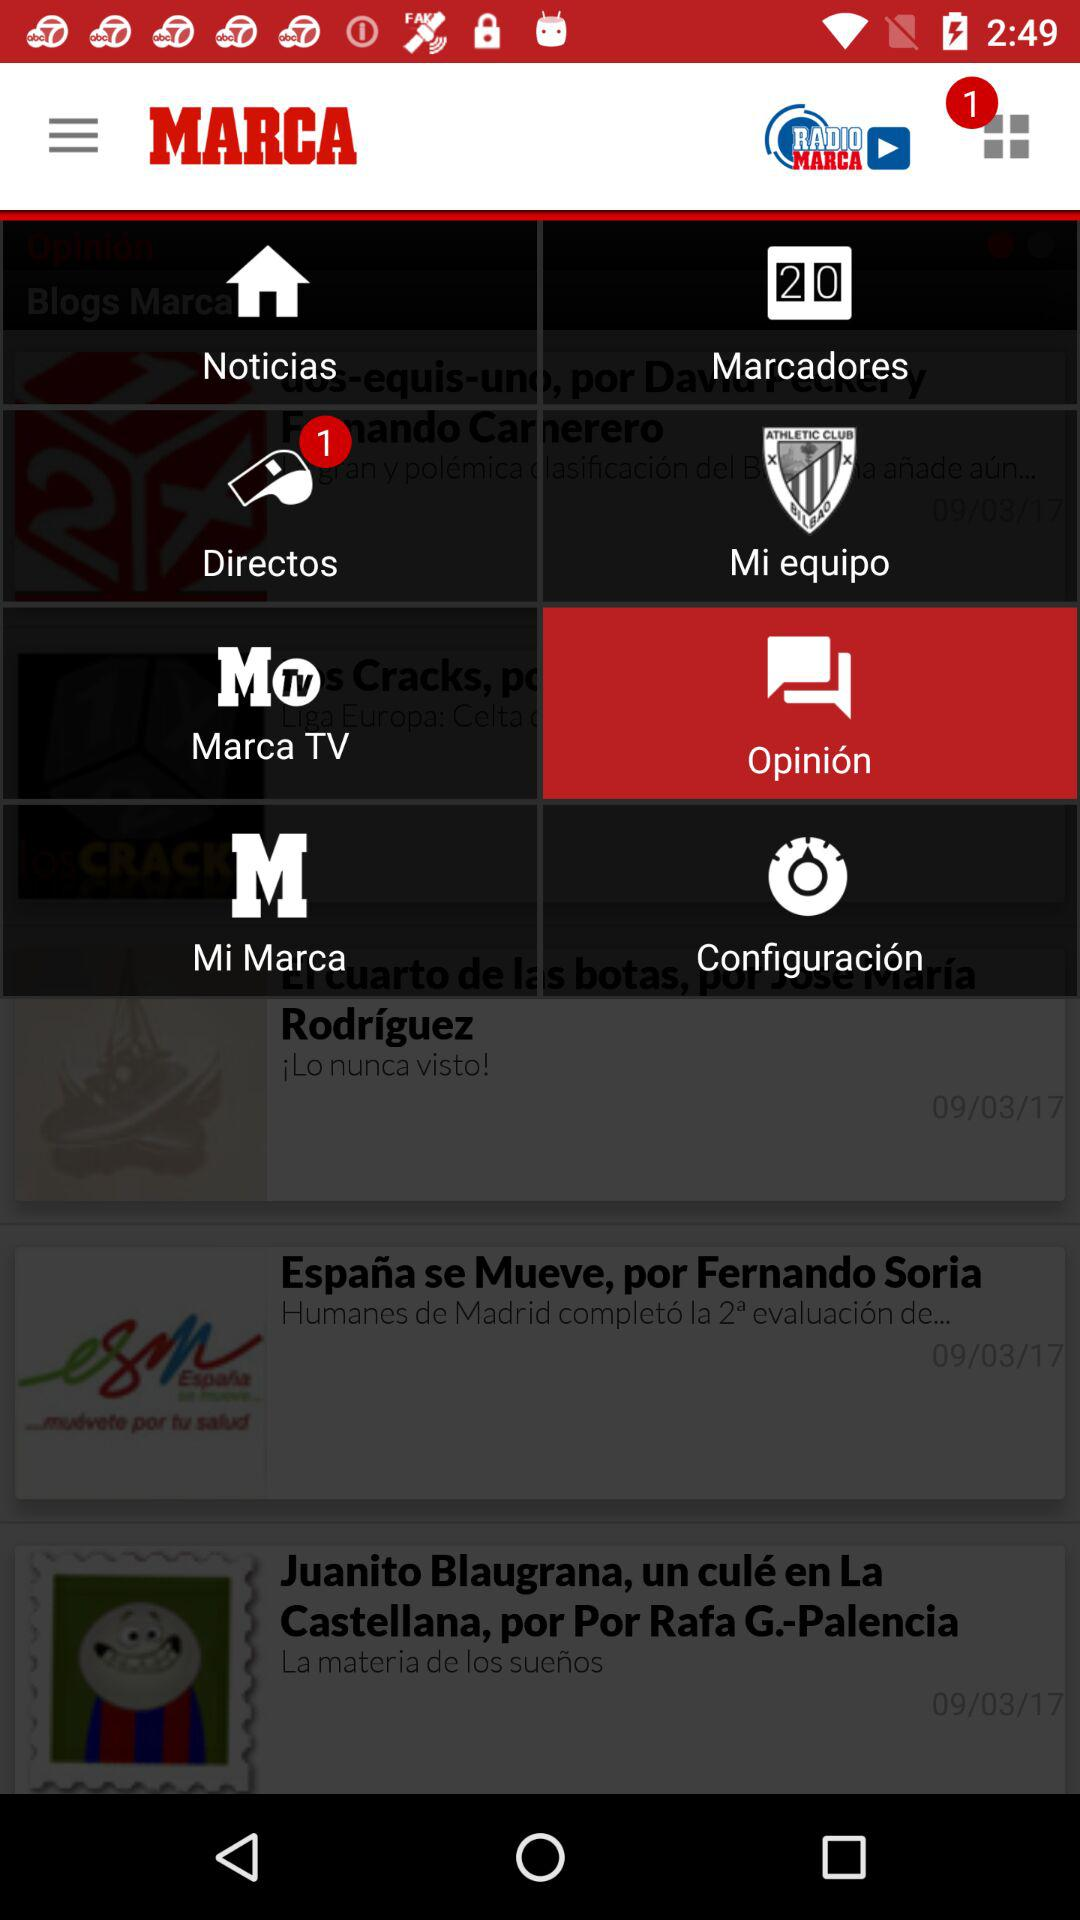How many notifications are there in directos? There is only 1 notification in directos. 